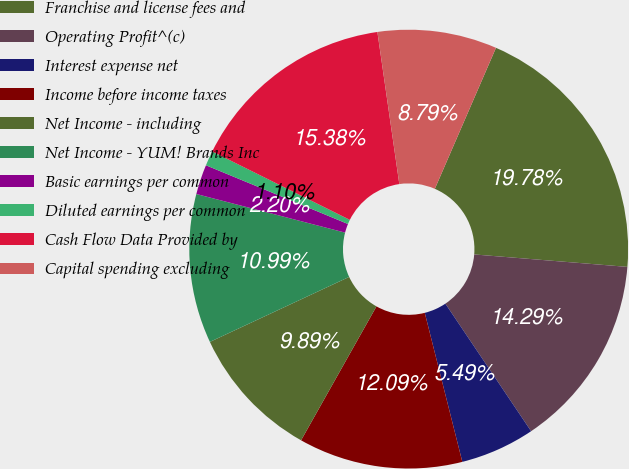Convert chart. <chart><loc_0><loc_0><loc_500><loc_500><pie_chart><fcel>Franchise and license fees and<fcel>Operating Profit^(c)<fcel>Interest expense net<fcel>Income before income taxes<fcel>Net Income - including<fcel>Net Income - YUM! Brands Inc<fcel>Basic earnings per common<fcel>Diluted earnings per common<fcel>Cash Flow Data Provided by<fcel>Capital spending excluding<nl><fcel>19.78%<fcel>14.29%<fcel>5.49%<fcel>12.09%<fcel>9.89%<fcel>10.99%<fcel>2.2%<fcel>1.1%<fcel>15.38%<fcel>8.79%<nl></chart> 